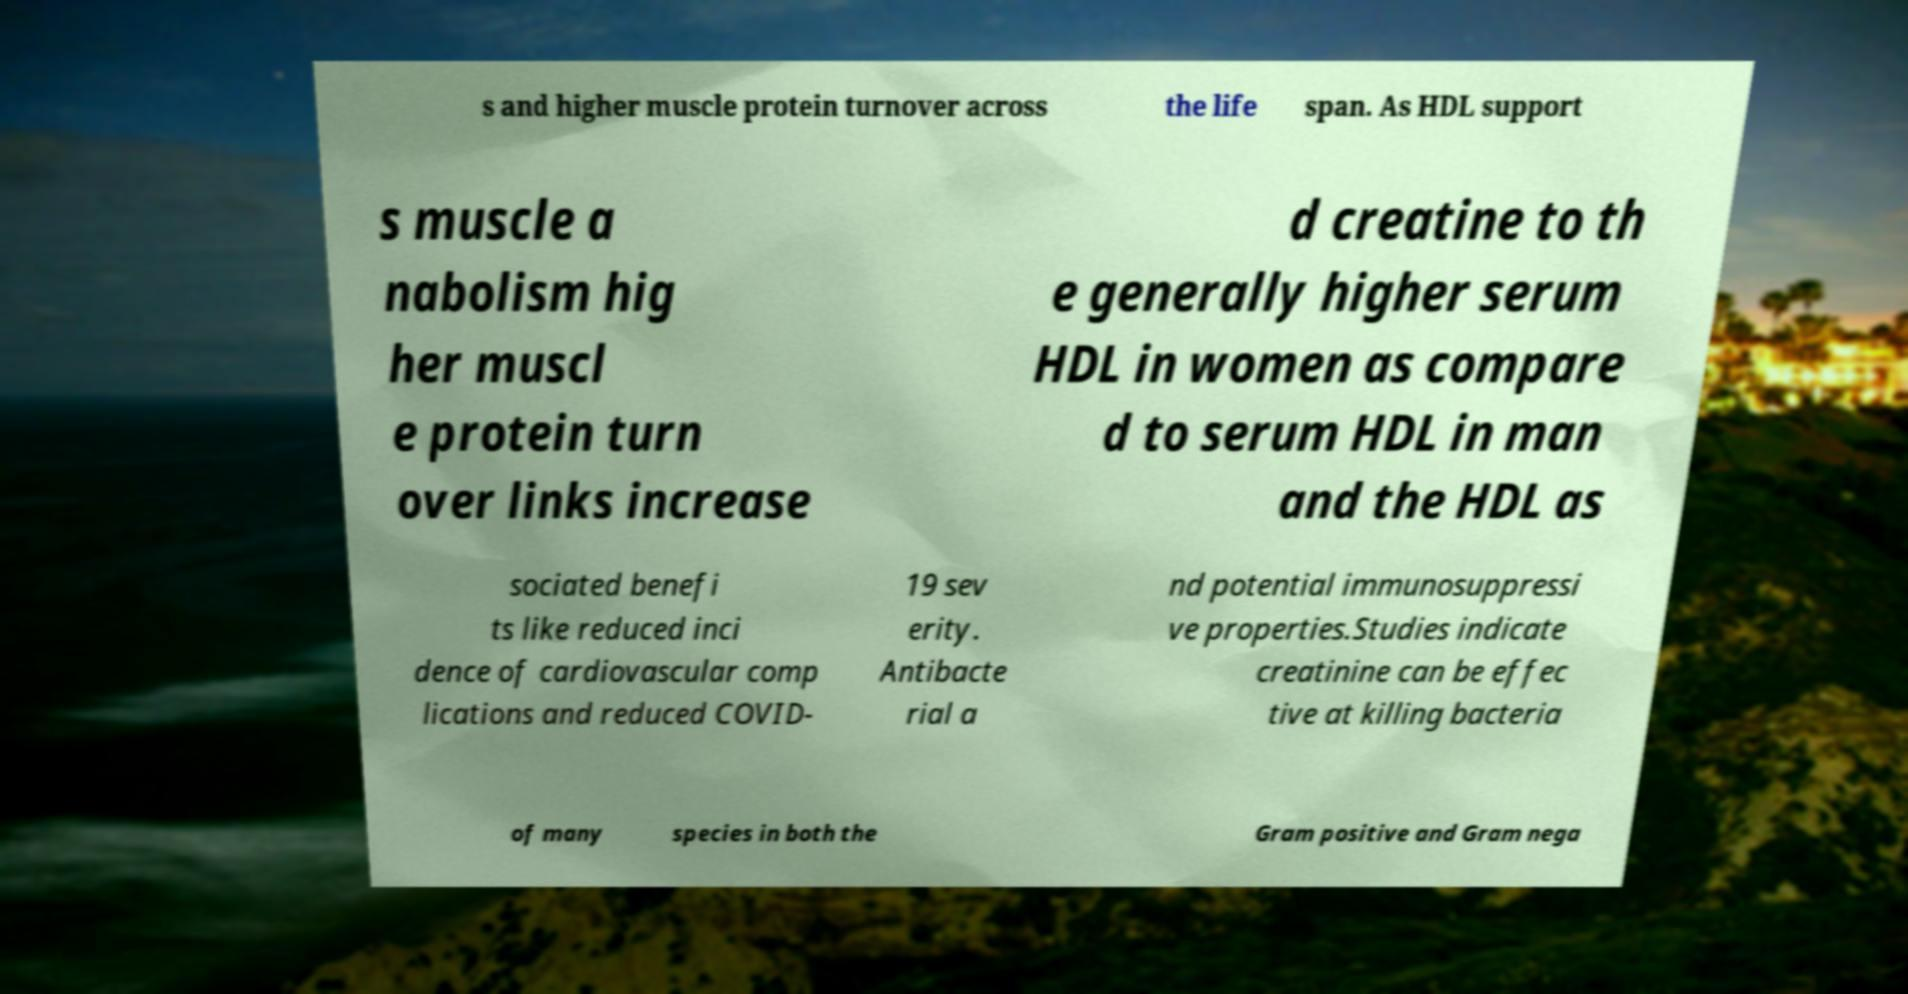Can you read and provide the text displayed in the image?This photo seems to have some interesting text. Can you extract and type it out for me? s and higher muscle protein turnover across the life span. As HDL support s muscle a nabolism hig her muscl e protein turn over links increase d creatine to th e generally higher serum HDL in women as compare d to serum HDL in man and the HDL as sociated benefi ts like reduced inci dence of cardiovascular comp lications and reduced COVID- 19 sev erity. Antibacte rial a nd potential immunosuppressi ve properties.Studies indicate creatinine can be effec tive at killing bacteria of many species in both the Gram positive and Gram nega 